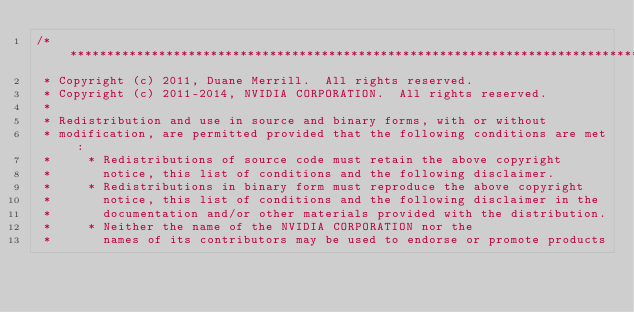Convert code to text. <code><loc_0><loc_0><loc_500><loc_500><_Cuda_>/******************************************************************************
 * Copyright (c) 2011, Duane Merrill.  All rights reserved.
 * Copyright (c) 2011-2014, NVIDIA CORPORATION.  All rights reserved.
 *
 * Redistribution and use in source and binary forms, with or without
 * modification, are permitted provided that the following conditions are met:
 *     * Redistributions of source code must retain the above copyright
 *       notice, this list of conditions and the following disclaimer.
 *     * Redistributions in binary form must reproduce the above copyright
 *       notice, this list of conditions and the following disclaimer in the
 *       documentation and/or other materials provided with the distribution.
 *     * Neither the name of the NVIDIA CORPORATION nor the
 *       names of its contributors may be used to endorse or promote products</code> 